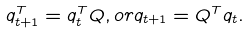<formula> <loc_0><loc_0><loc_500><loc_500>q ^ { T } _ { t + 1 } = q ^ { T } _ { t } Q , o r q _ { t + 1 } = Q ^ { T } q _ { t } .</formula> 